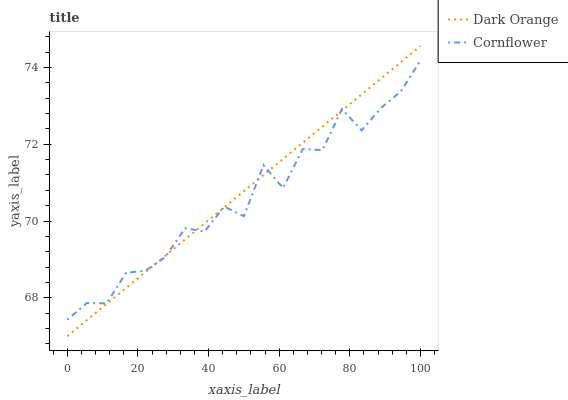Does Cornflower have the minimum area under the curve?
Answer yes or no. Yes. Does Dark Orange have the maximum area under the curve?
Answer yes or no. Yes. Does Cornflower have the maximum area under the curve?
Answer yes or no. No. Is Dark Orange the smoothest?
Answer yes or no. Yes. Is Cornflower the roughest?
Answer yes or no. Yes. Is Cornflower the smoothest?
Answer yes or no. No. Does Dark Orange have the lowest value?
Answer yes or no. Yes. Does Cornflower have the lowest value?
Answer yes or no. No. Does Dark Orange have the highest value?
Answer yes or no. Yes. Does Cornflower have the highest value?
Answer yes or no. No. Does Dark Orange intersect Cornflower?
Answer yes or no. Yes. Is Dark Orange less than Cornflower?
Answer yes or no. No. Is Dark Orange greater than Cornflower?
Answer yes or no. No. 